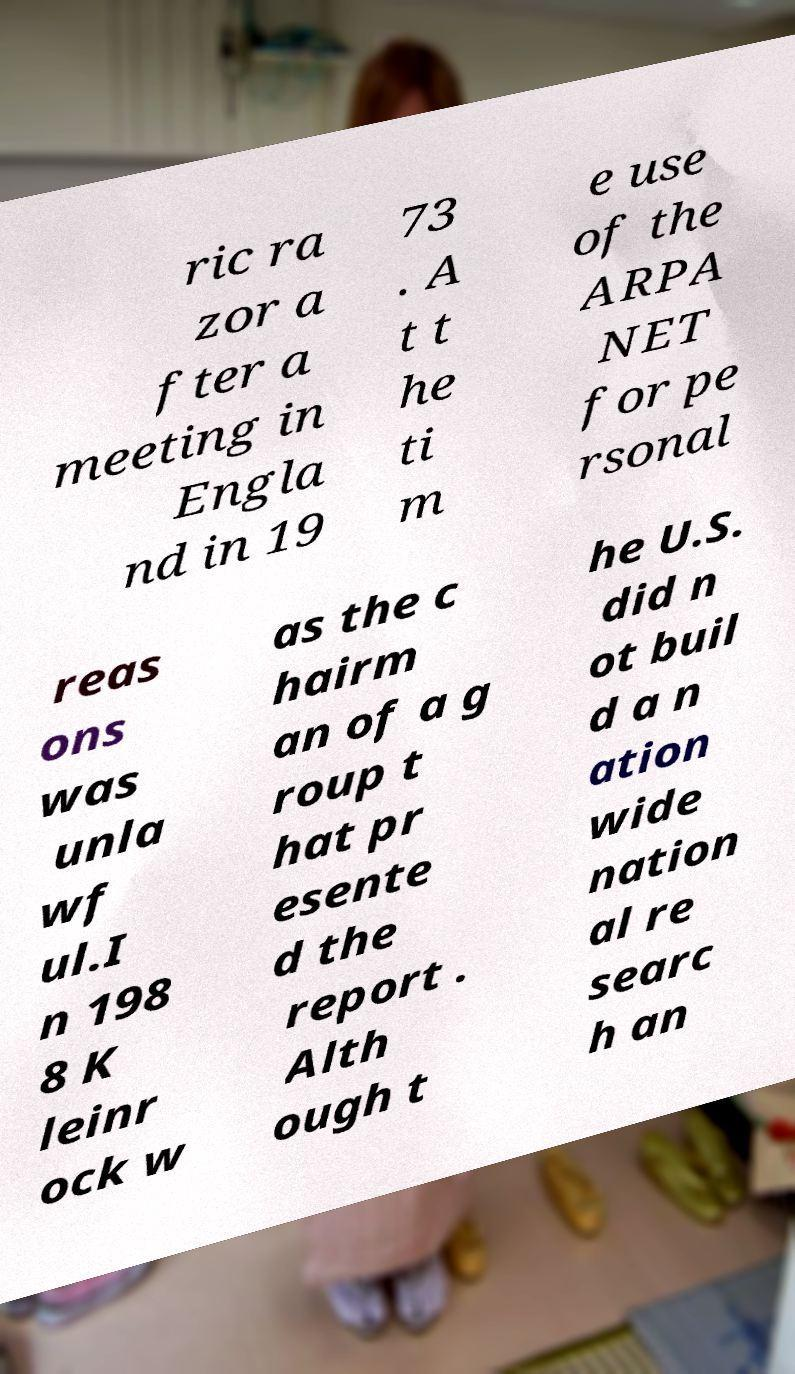Please read and relay the text visible in this image. What does it say? ric ra zor a fter a meeting in Engla nd in 19 73 . A t t he ti m e use of the ARPA NET for pe rsonal reas ons was unla wf ul.I n 198 8 K leinr ock w as the c hairm an of a g roup t hat pr esente d the report . Alth ough t he U.S. did n ot buil d a n ation wide nation al re searc h an 